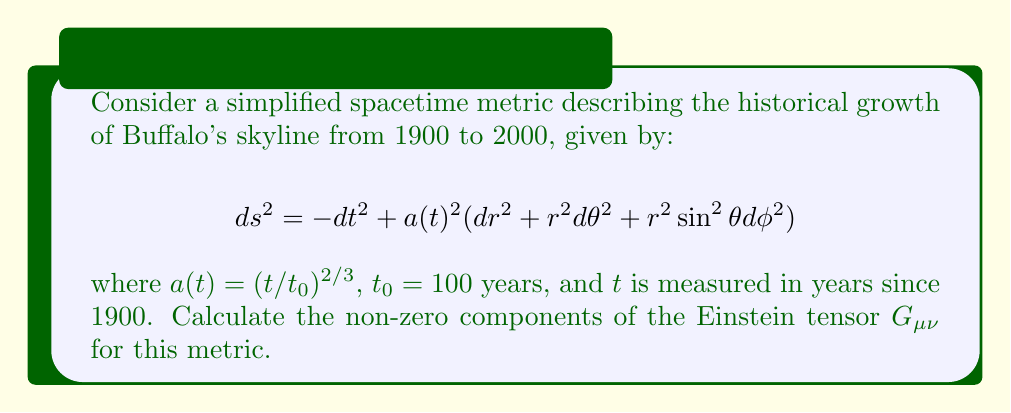Provide a solution to this math problem. Let's approach this step-by-step:

1) First, we need to calculate the Christoffel symbols. For a metric of this form (known as a Friedmann-Lemaître-Robertson-Walker metric), the non-zero Christoffel symbols are:

   $$\Gamma^0_{ii} = a\dot{a}$$
   $$\Gamma^i_{0i} = \Gamma^i_{i0} = \frac{\dot{a}}{a}$$

   where $i = 1,2,3$ and dot denotes derivative with respect to $t$.

2) We calculate $\dot{a}$ and $\ddot{a}$:

   $$\dot{a} = \frac{2}{3t_0}(\frac{t}{t_0})^{-1/3}$$
   $$\ddot{a} = -\frac{2}{9t_0^2}(\frac{t}{t_0})^{-4/3}$$

3) Next, we calculate the Ricci tensor components:

   $$R_{00} = -3\frac{\ddot{a}}{a}$$
   $$R_{ii} = a\ddot{a} + 2\dot{a}^2 + 2k$$

   where $k=0$ for a flat universe.

4) The Ricci scalar is:

   $$R = \frac{6}{a^2}(a\ddot{a} + \dot{a}^2 + k)$$

5) Now we can calculate the Einstein tensor:

   $$G_{\mu\nu} = R_{\mu\nu} - \frac{1}{2}g_{\mu\nu}R$$

   The non-zero components are:

   $$G_{00} = 3(\frac{\dot{a}}{a})^2$$
   $$G_{ii} = -(2a\ddot{a} + \dot{a}^2 + 2k)$$

6) Substituting our expressions for $a$, $\dot{a}$, and $\ddot{a}$:

   $$G_{00} = \frac{4}{3t^2}$$
   $$G_{ii} = -\frac{4}{3t^2}a^2$$
Answer: $G_{00} = \frac{4}{3t^2}$, $G_{ii} = -\frac{4}{3t^2}(\frac{t}{t_0})^{4/3}$ 